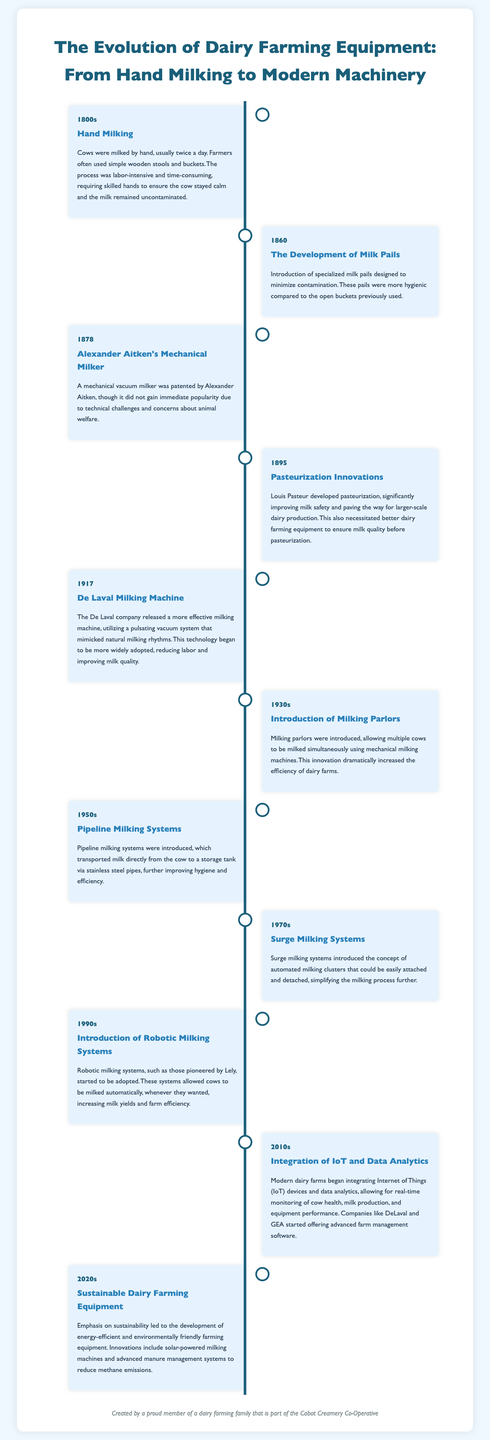What year was the mechanical vacuum milker patented? The mechanical vacuum milker was patented by Alexander Aitken in the year 1878.
Answer: 1878 What did Louis Pasteur develop in 1895? In 1895, Louis Pasteur developed pasteurization, which significantly improved milk safety.
Answer: Pasteurization What was introduced in the 1950s for transporting milk? In the 1950s, pipeline milking systems were introduced for transporting milk directly to storage tanks.
Answer: Pipeline milking systems Which company released a milking machine in 1917? The De Laval company released a more effective milking machine in 1917.
Answer: De Laval What concept was introduced in the 1970s? The concept introduced in the 1970s was surge milking systems with automated milking clusters.
Answer: Surge milking systems What decade saw the rise of robotic milking systems? The 1990s saw the introduction of robotic milking systems, such as those by Lely.
Answer: 1990s How did the integration of IoT impact modern dairy farms? The integration of IoT devices allowed for real-time monitoring of cow health and milk production on modern dairy farms.
Answer: Real-time monitoring What is a notable feature of sustainable dairy farming equipment introduced in the 2020s? A notable feature is the development of energy-efficient and environmentally friendly farming equipment.
Answer: Energy-efficient Which innovation became popular following the introduction of milking parlors in the 1930s? The introduction of milking parlors in the 1930s allowed multiple cows to be milked simultaneously, increasing efficiency.
Answer: Increased efficiency 